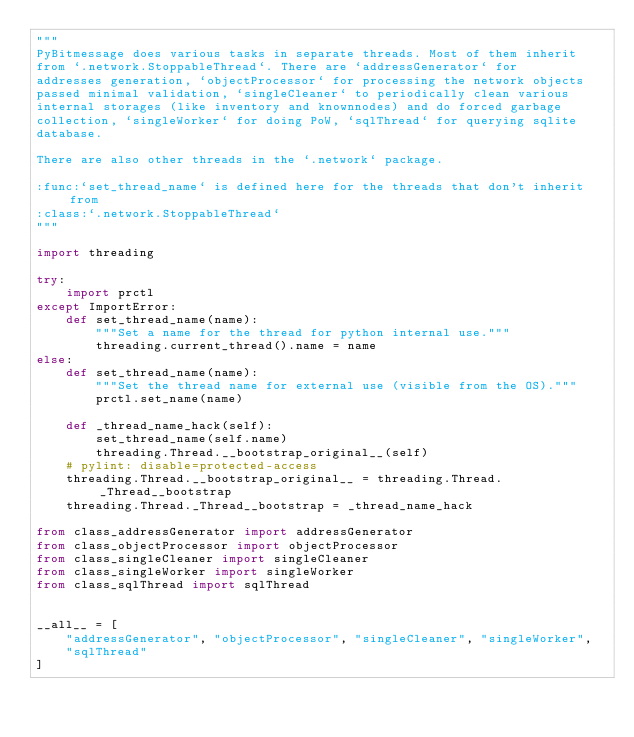<code> <loc_0><loc_0><loc_500><loc_500><_Python_>"""
PyBitmessage does various tasks in separate threads. Most of them inherit
from `.network.StoppableThread`. There are `addressGenerator` for
addresses generation, `objectProcessor` for processing the network objects
passed minimal validation, `singleCleaner` to periodically clean various
internal storages (like inventory and knownnodes) and do forced garbage
collection, `singleWorker` for doing PoW, `sqlThread` for querying sqlite
database.

There are also other threads in the `.network` package.

:func:`set_thread_name` is defined here for the threads that don't inherit from
:class:`.network.StoppableThread`
"""

import threading

try:
    import prctl
except ImportError:
    def set_thread_name(name):
        """Set a name for the thread for python internal use."""
        threading.current_thread().name = name
else:
    def set_thread_name(name):
        """Set the thread name for external use (visible from the OS)."""
        prctl.set_name(name)

    def _thread_name_hack(self):
        set_thread_name(self.name)
        threading.Thread.__bootstrap_original__(self)
    # pylint: disable=protected-access
    threading.Thread.__bootstrap_original__ = threading.Thread._Thread__bootstrap
    threading.Thread._Thread__bootstrap = _thread_name_hack

from class_addressGenerator import addressGenerator
from class_objectProcessor import objectProcessor
from class_singleCleaner import singleCleaner
from class_singleWorker import singleWorker
from class_sqlThread import sqlThread


__all__ = [
    "addressGenerator", "objectProcessor", "singleCleaner", "singleWorker",
    "sqlThread"
]
</code> 